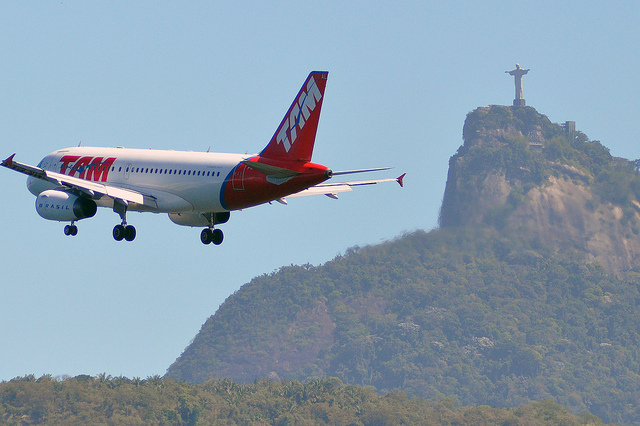How many wheels can you see on the airplane? I can identify a total of eight wheels on the airplane. The landing gear configuration, visible in the image, includes four main wheels on each side of the aircraft. 